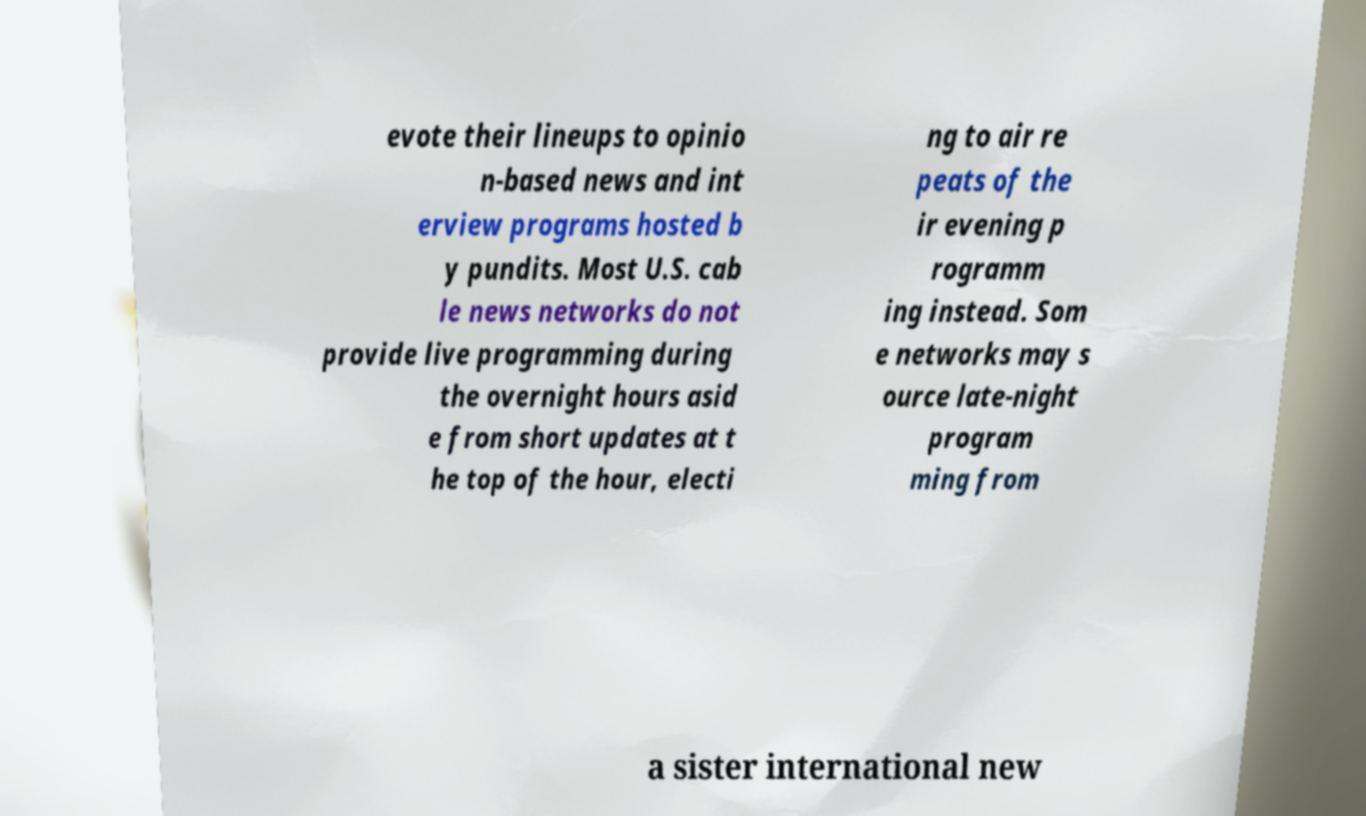For documentation purposes, I need the text within this image transcribed. Could you provide that? evote their lineups to opinio n-based news and int erview programs hosted b y pundits. Most U.S. cab le news networks do not provide live programming during the overnight hours asid e from short updates at t he top of the hour, electi ng to air re peats of the ir evening p rogramm ing instead. Som e networks may s ource late-night program ming from a sister international new 